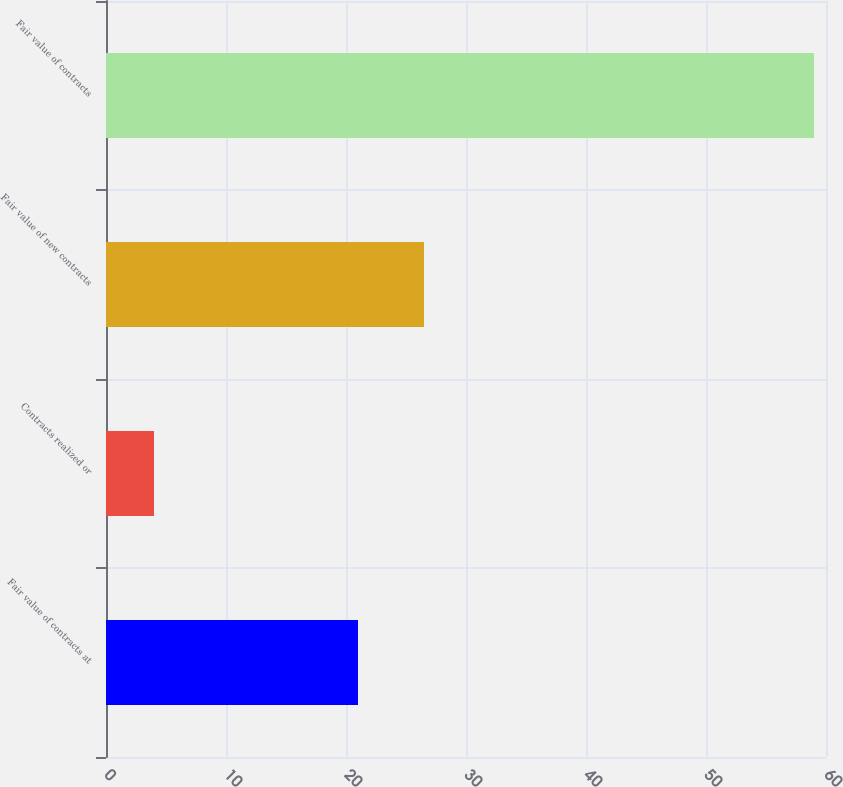Convert chart. <chart><loc_0><loc_0><loc_500><loc_500><bar_chart><fcel>Fair value of contracts at<fcel>Contracts realized or<fcel>Fair value of new contracts<fcel>Fair value of contracts<nl><fcel>21<fcel>4<fcel>26.5<fcel>59<nl></chart> 